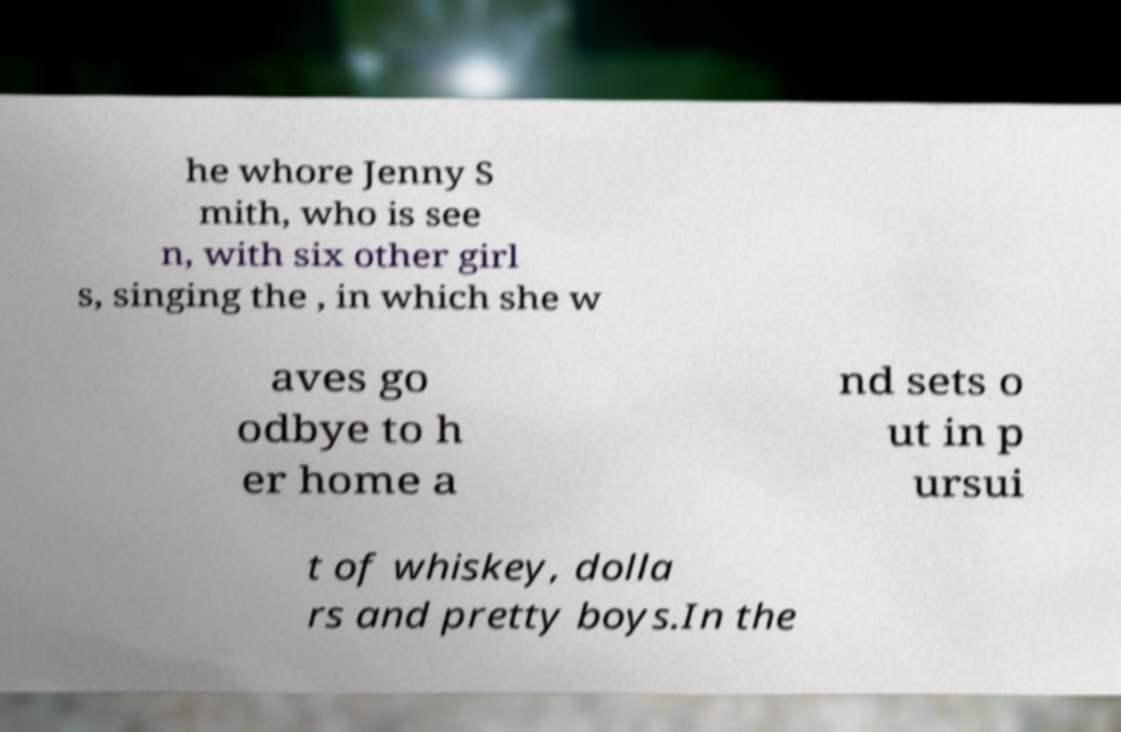What messages or text are displayed in this image? I need them in a readable, typed format. he whore Jenny S mith, who is see n, with six other girl s, singing the , in which she w aves go odbye to h er home a nd sets o ut in p ursui t of whiskey, dolla rs and pretty boys.In the 